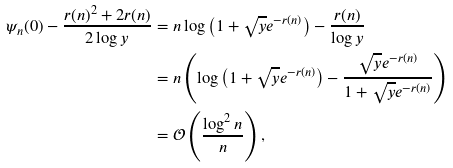<formula> <loc_0><loc_0><loc_500><loc_500>\psi _ { n } ( 0 ) - \frac { r ( n ) ^ { 2 } + 2 r ( n ) } { 2 \log y } & = n \log \left ( 1 + \sqrt { y } e ^ { - r ( n ) } \right ) - \frac { r ( n ) } { \log y } \\ & = n \left ( \log \left ( 1 + \sqrt { y } e ^ { - r ( n ) } \right ) - \frac { \sqrt { y } e ^ { - r ( n ) } } { 1 + \sqrt { y } e ^ { - r ( n ) } } \right ) \\ & = \mathcal { O } \left ( \frac { \log ^ { 2 } n } { n } \right ) ,</formula> 